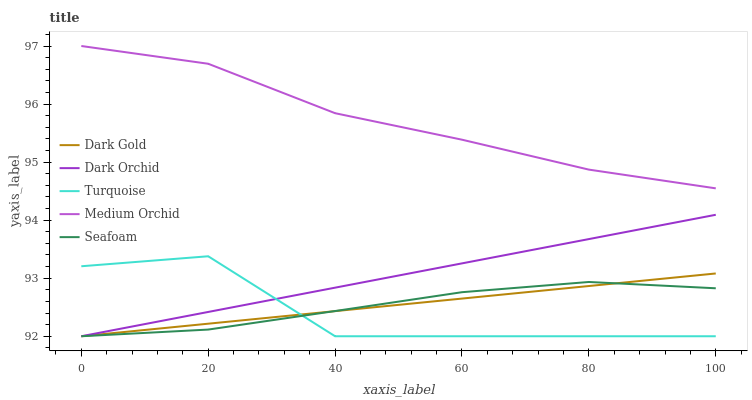Does Turquoise have the minimum area under the curve?
Answer yes or no. Yes. Does Medium Orchid have the maximum area under the curve?
Answer yes or no. Yes. Does Seafoam have the minimum area under the curve?
Answer yes or no. No. Does Seafoam have the maximum area under the curve?
Answer yes or no. No. Is Dark Orchid the smoothest?
Answer yes or no. Yes. Is Turquoise the roughest?
Answer yes or no. Yes. Is Medium Orchid the smoothest?
Answer yes or no. No. Is Medium Orchid the roughest?
Answer yes or no. No. Does Turquoise have the lowest value?
Answer yes or no. Yes. Does Medium Orchid have the lowest value?
Answer yes or no. No. Does Medium Orchid have the highest value?
Answer yes or no. Yes. Does Seafoam have the highest value?
Answer yes or no. No. Is Dark Gold less than Medium Orchid?
Answer yes or no. Yes. Is Medium Orchid greater than Dark Gold?
Answer yes or no. Yes. Does Dark Orchid intersect Turquoise?
Answer yes or no. Yes. Is Dark Orchid less than Turquoise?
Answer yes or no. No. Is Dark Orchid greater than Turquoise?
Answer yes or no. No. Does Dark Gold intersect Medium Orchid?
Answer yes or no. No. 